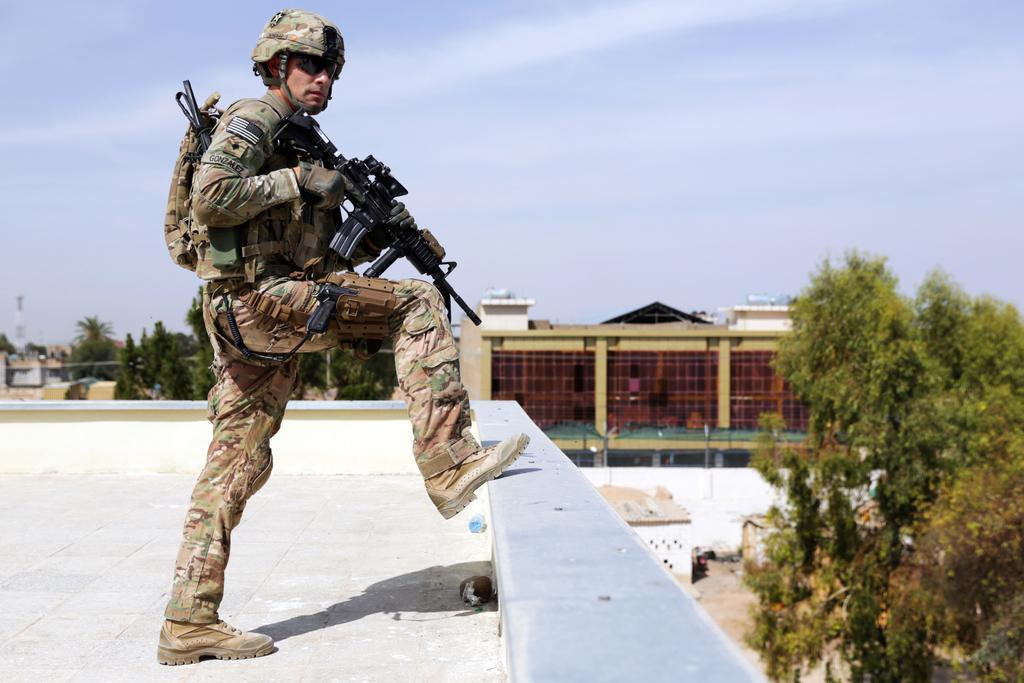In one or two sentences, can you explain what this image depicts? In the foreground of this image, there is a man wearing military dress, jacket, bag and holding a gun. On the right, there is a tree. In the background, there are trees, buildings and the sky. 